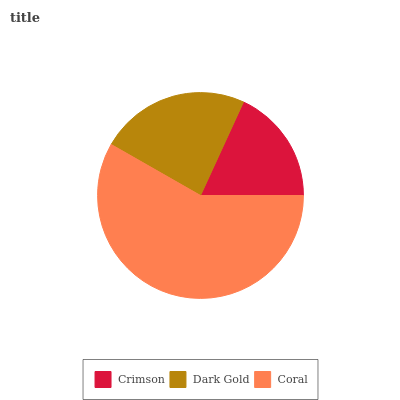Is Crimson the minimum?
Answer yes or no. Yes. Is Coral the maximum?
Answer yes or no. Yes. Is Dark Gold the minimum?
Answer yes or no. No. Is Dark Gold the maximum?
Answer yes or no. No. Is Dark Gold greater than Crimson?
Answer yes or no. Yes. Is Crimson less than Dark Gold?
Answer yes or no. Yes. Is Crimson greater than Dark Gold?
Answer yes or no. No. Is Dark Gold less than Crimson?
Answer yes or no. No. Is Dark Gold the high median?
Answer yes or no. Yes. Is Dark Gold the low median?
Answer yes or no. Yes. Is Crimson the high median?
Answer yes or no. No. Is Crimson the low median?
Answer yes or no. No. 